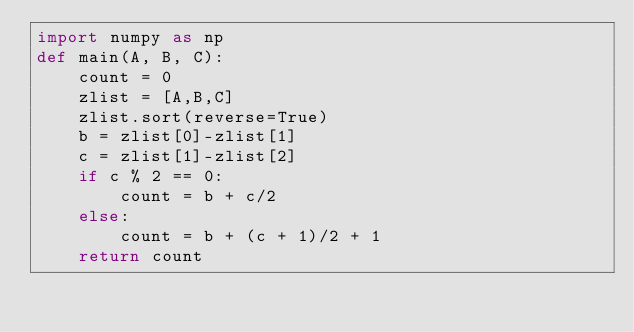Convert code to text. <code><loc_0><loc_0><loc_500><loc_500><_Python_>import numpy as np
def main(A, B, C):
    count = 0
    zlist = [A,B,C]
    zlist.sort(reverse=True)
    b = zlist[0]-zlist[1]
    c = zlist[1]-zlist[2]
    if c % 2 == 0:
        count = b + c/2
    else:
        count = b + (c + 1)/2 + 1    
    return count</code> 